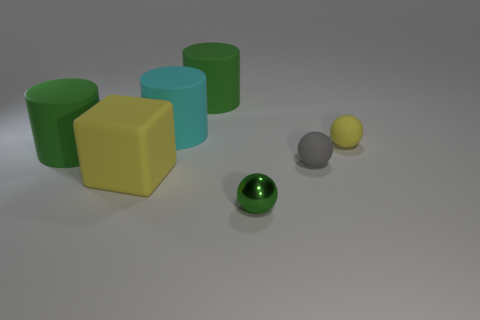Subtract all large green matte cylinders. How many cylinders are left? 1 Subtract all cyan cubes. How many green cylinders are left? 2 Add 1 big green objects. How many objects exist? 8 Subtract all cyan cylinders. How many cylinders are left? 2 Subtract all blue cylinders. Subtract all green balls. How many cylinders are left? 3 Subtract all gray balls. Subtract all small cyan cylinders. How many objects are left? 6 Add 2 metallic spheres. How many metallic spheres are left? 3 Add 7 small balls. How many small balls exist? 10 Subtract 0 red cylinders. How many objects are left? 7 Subtract all cylinders. How many objects are left? 4 